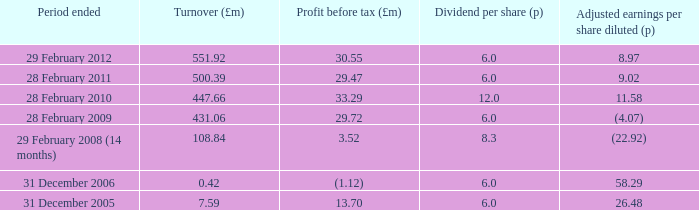How many items appear in the dividend per share when the turnover is 0.42? 1.0. 